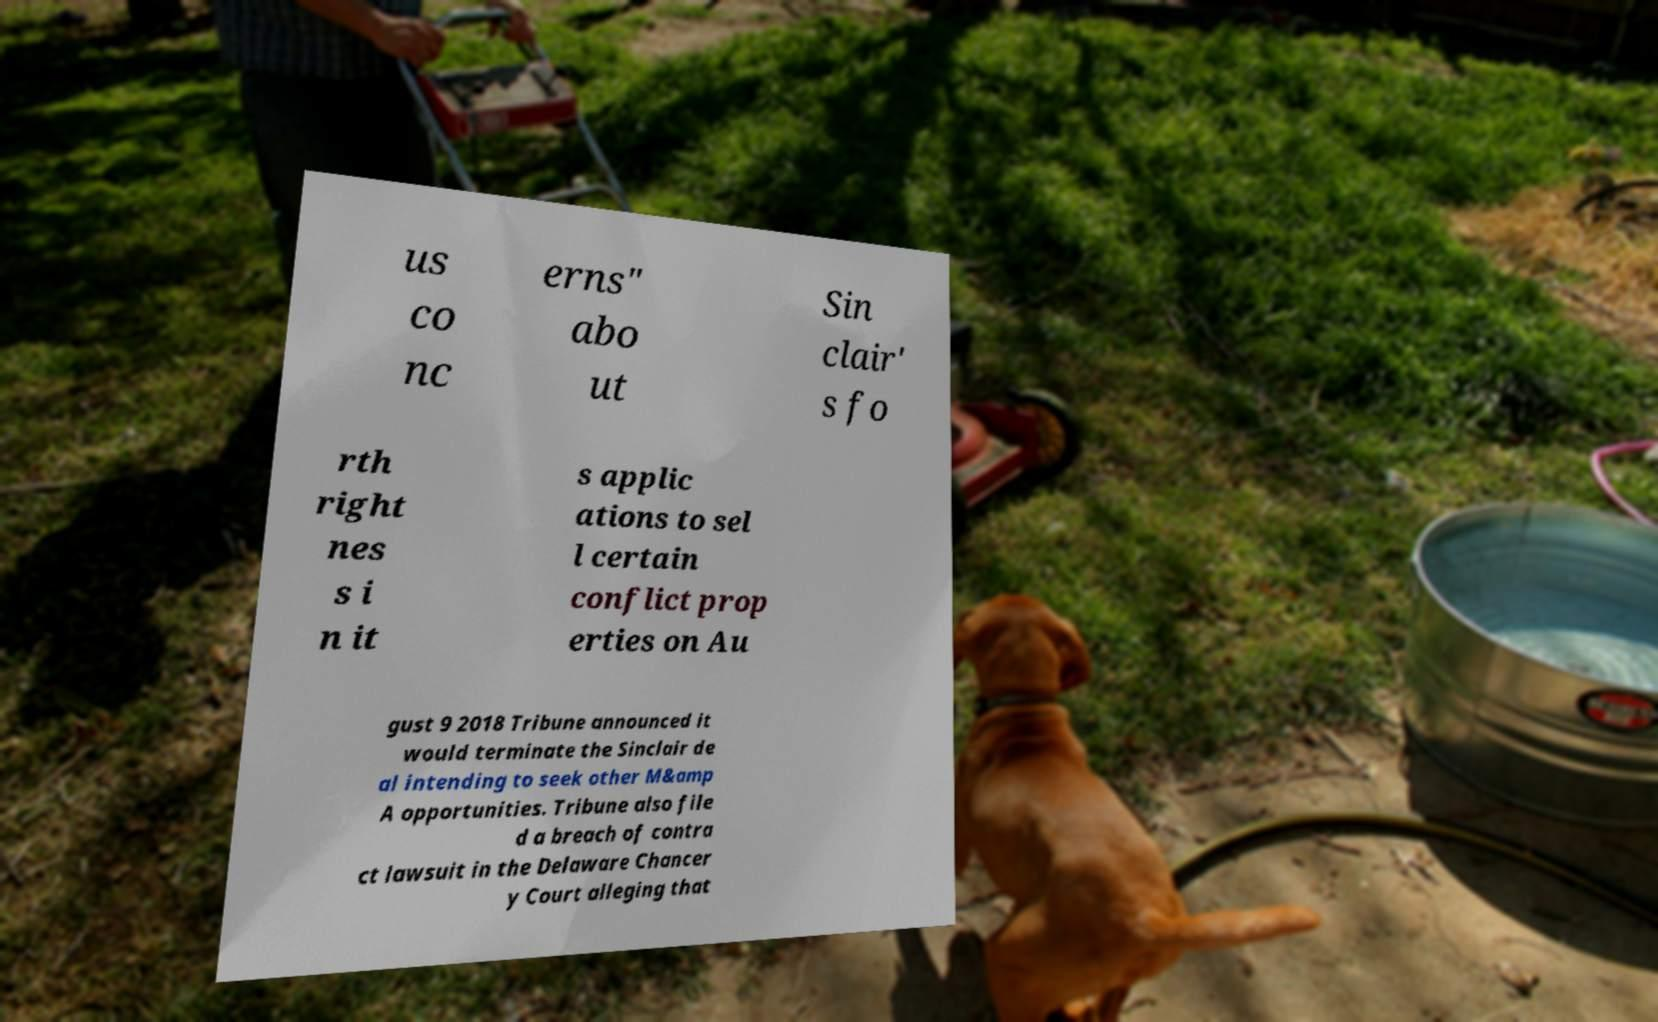There's text embedded in this image that I need extracted. Can you transcribe it verbatim? us co nc erns" abo ut Sin clair' s fo rth right nes s i n it s applic ations to sel l certain conflict prop erties on Au gust 9 2018 Tribune announced it would terminate the Sinclair de al intending to seek other M&amp A opportunities. Tribune also file d a breach of contra ct lawsuit in the Delaware Chancer y Court alleging that 